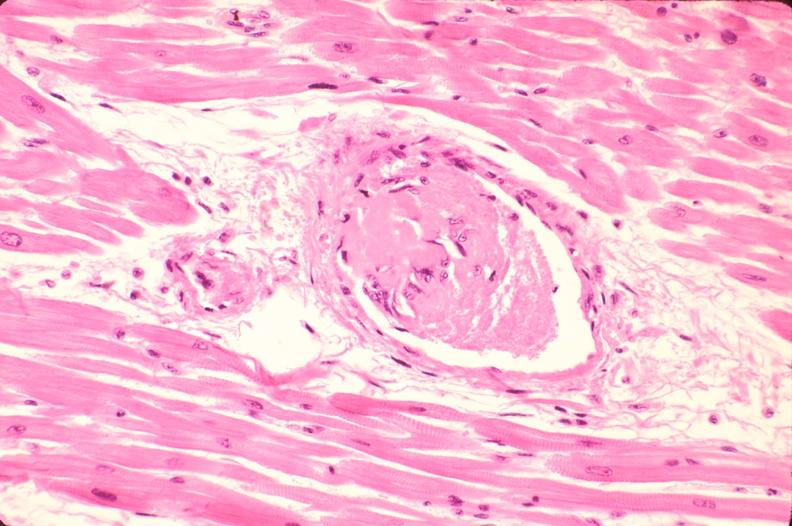does this image show heart, microthrombi, thrombotic thrombocytopenic purpura?
Answer the question using a single word or phrase. Yes 